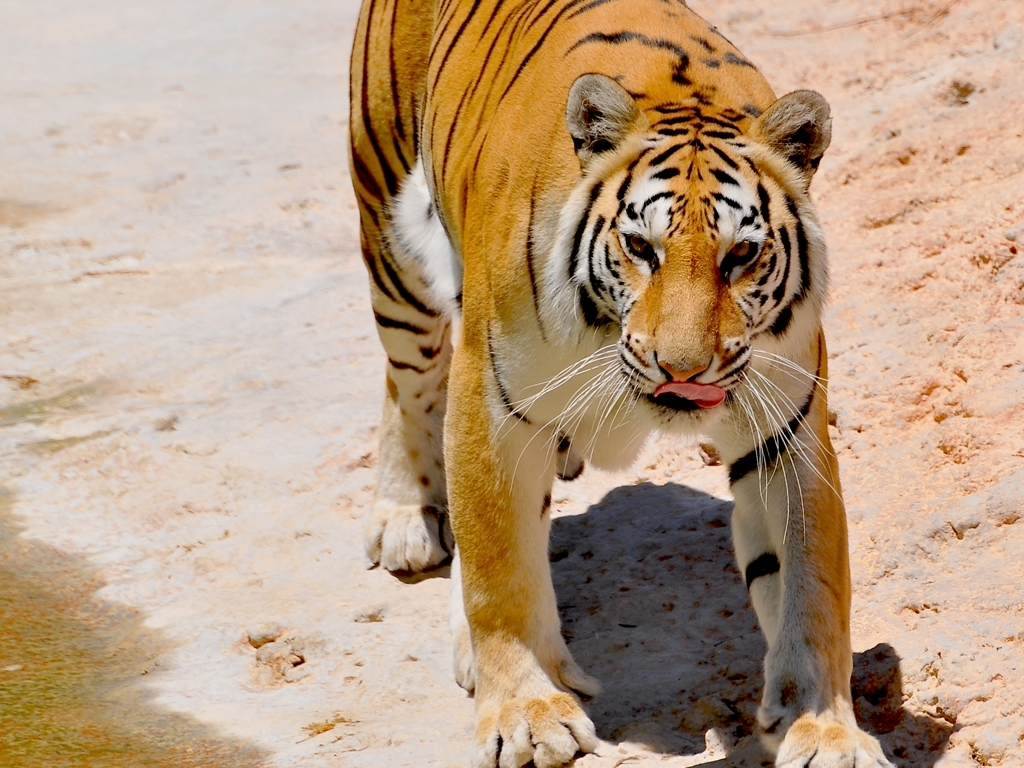Could you describe the tiger's physical condition? The tiger in the image looks to be in good physical condition. Its coat is vibrant with well-defined stripes, and the tiger seems well-muscled, indicating it is likely well-fed and healthy. The alert expression and focused gaze suggest it is attentive and engaged with its environment. 